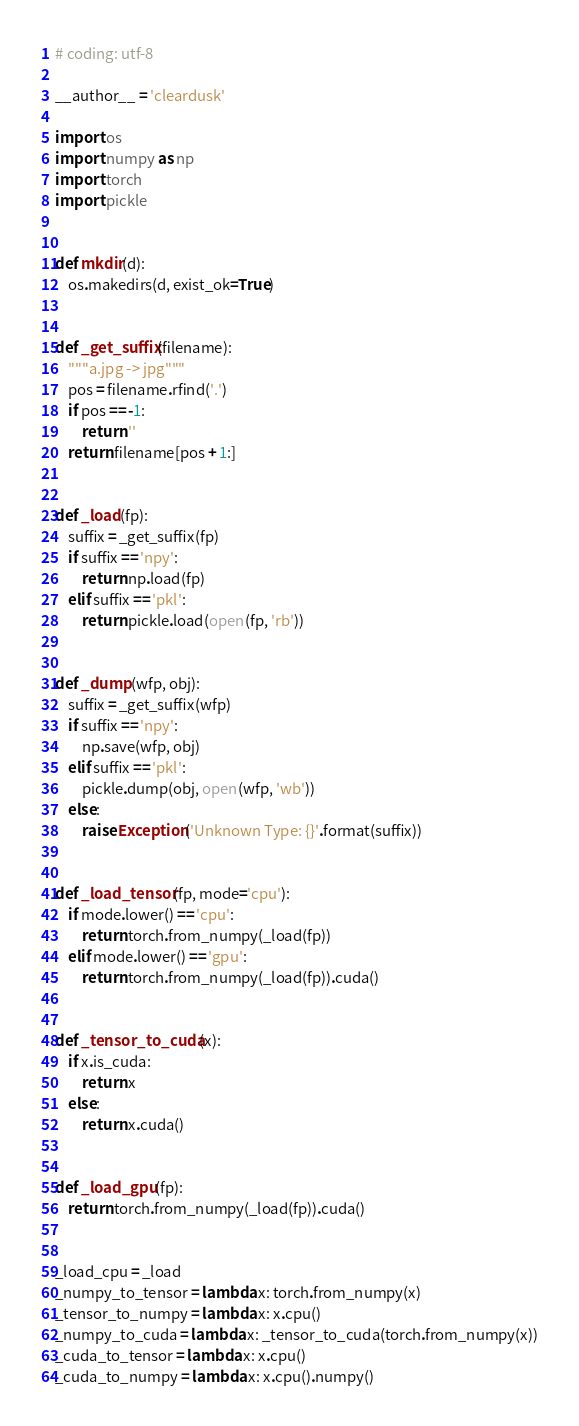Convert code to text. <code><loc_0><loc_0><loc_500><loc_500><_Python_># coding: utf-8

__author__ = 'cleardusk'

import os
import numpy as np
import torch
import pickle


def mkdir(d):
    os.makedirs(d, exist_ok=True)


def _get_suffix(filename):
    """a.jpg -> jpg"""
    pos = filename.rfind('.')
    if pos == -1:
        return ''
    return filename[pos + 1:]


def _load(fp):
    suffix = _get_suffix(fp)
    if suffix == 'npy':
        return np.load(fp)
    elif suffix == 'pkl':
        return pickle.load(open(fp, 'rb'))


def _dump(wfp, obj):
    suffix = _get_suffix(wfp)
    if suffix == 'npy':
        np.save(wfp, obj)
    elif suffix == 'pkl':
        pickle.dump(obj, open(wfp, 'wb'))
    else:
        raise Exception('Unknown Type: {}'.format(suffix))


def _load_tensor(fp, mode='cpu'):
    if mode.lower() == 'cpu':
        return torch.from_numpy(_load(fp))
    elif mode.lower() == 'gpu':
        return torch.from_numpy(_load(fp)).cuda()


def _tensor_to_cuda(x):
    if x.is_cuda:
        return x
    else:
        return x.cuda()


def _load_gpu(fp):
    return torch.from_numpy(_load(fp)).cuda()


_load_cpu = _load
_numpy_to_tensor = lambda x: torch.from_numpy(x)
_tensor_to_numpy = lambda x: x.cpu()
_numpy_to_cuda = lambda x: _tensor_to_cuda(torch.from_numpy(x))
_cuda_to_tensor = lambda x: x.cpu()
_cuda_to_numpy = lambda x: x.cpu().numpy()
</code> 